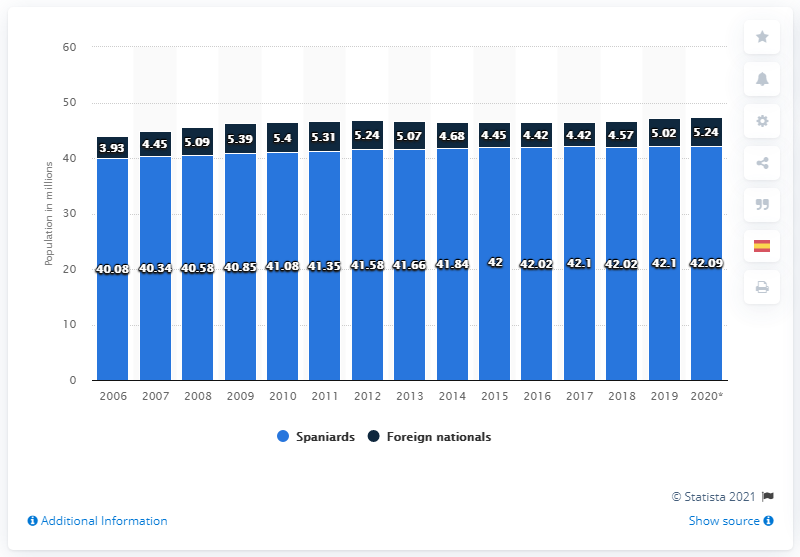Give some essential details in this illustration. In the period between 2019 and 2020, there were 41.84 foreign-born residents living in Spain. In 2006, the total Spanish-born and foreign population residing in Spain was approximately 44.01 million. In 2006, there was a population of 40.08 million Spanish-born individuals residing in Spain. The Spanish-born population in January 2020 was 41.84... 